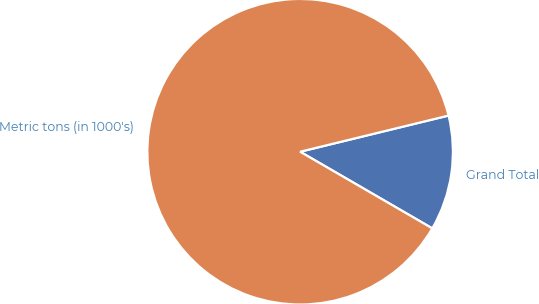Convert chart. <chart><loc_0><loc_0><loc_500><loc_500><pie_chart><fcel>Grand Total<fcel>Metric tons (in 1000's)<nl><fcel>12.17%<fcel>87.83%<nl></chart> 